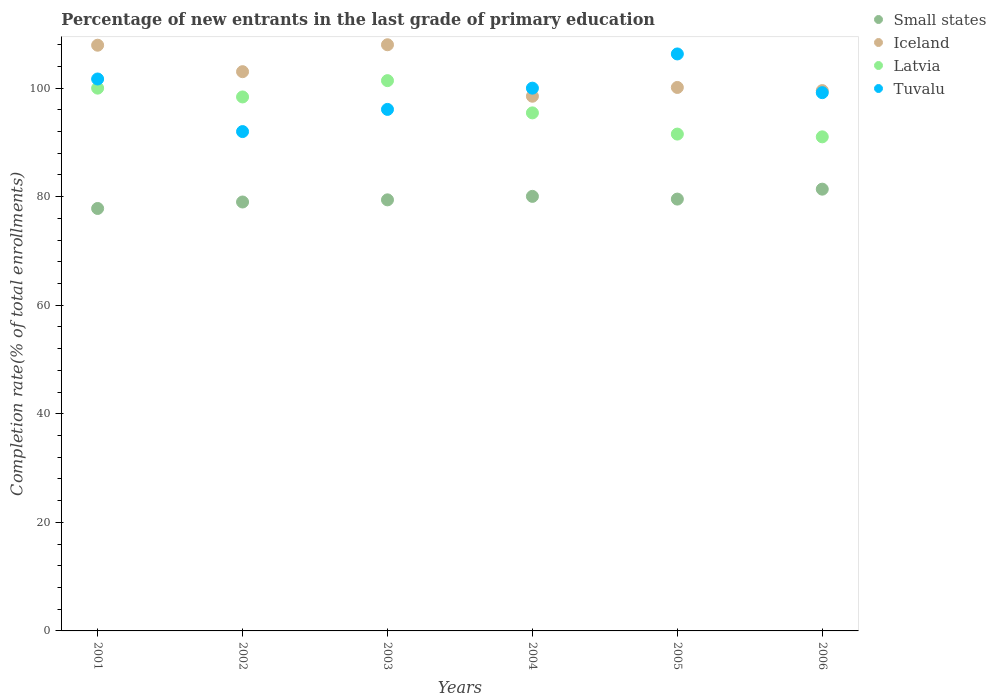How many different coloured dotlines are there?
Provide a succinct answer. 4. Is the number of dotlines equal to the number of legend labels?
Provide a succinct answer. Yes. What is the percentage of new entrants in Small states in 2002?
Ensure brevity in your answer.  79.03. Across all years, what is the maximum percentage of new entrants in Latvia?
Keep it short and to the point. 101.39. Across all years, what is the minimum percentage of new entrants in Tuvalu?
Offer a very short reply. 92. In which year was the percentage of new entrants in Iceland maximum?
Your response must be concise. 2003. In which year was the percentage of new entrants in Latvia minimum?
Provide a short and direct response. 2006. What is the total percentage of new entrants in Small states in the graph?
Offer a very short reply. 477.29. What is the difference between the percentage of new entrants in Iceland in 2001 and that in 2002?
Your response must be concise. 4.88. What is the difference between the percentage of new entrants in Small states in 2006 and the percentage of new entrants in Latvia in 2003?
Your answer should be very brief. -19.99. What is the average percentage of new entrants in Small states per year?
Offer a terse response. 79.55. In the year 2002, what is the difference between the percentage of new entrants in Tuvalu and percentage of new entrants in Latvia?
Provide a short and direct response. -6.38. In how many years, is the percentage of new entrants in Small states greater than 52 %?
Give a very brief answer. 6. What is the ratio of the percentage of new entrants in Iceland in 2003 to that in 2005?
Give a very brief answer. 1.08. Is the percentage of new entrants in Tuvalu in 2002 less than that in 2006?
Ensure brevity in your answer.  Yes. Is the difference between the percentage of new entrants in Tuvalu in 2005 and 2006 greater than the difference between the percentage of new entrants in Latvia in 2005 and 2006?
Your answer should be very brief. Yes. What is the difference between the highest and the second highest percentage of new entrants in Tuvalu?
Your answer should be compact. 4.61. What is the difference between the highest and the lowest percentage of new entrants in Small states?
Provide a succinct answer. 3.56. Is the sum of the percentage of new entrants in Tuvalu in 2003 and 2006 greater than the maximum percentage of new entrants in Latvia across all years?
Provide a short and direct response. Yes. Is it the case that in every year, the sum of the percentage of new entrants in Tuvalu and percentage of new entrants in Latvia  is greater than the percentage of new entrants in Iceland?
Provide a short and direct response. Yes. Is the percentage of new entrants in Small states strictly greater than the percentage of new entrants in Iceland over the years?
Keep it short and to the point. No. How many years are there in the graph?
Provide a succinct answer. 6. Does the graph contain any zero values?
Your answer should be very brief. No. Does the graph contain grids?
Your answer should be compact. No. Where does the legend appear in the graph?
Your answer should be very brief. Top right. How many legend labels are there?
Keep it short and to the point. 4. How are the legend labels stacked?
Offer a very short reply. Vertical. What is the title of the graph?
Provide a short and direct response. Percentage of new entrants in the last grade of primary education. What is the label or title of the Y-axis?
Offer a very short reply. Completion rate(% of total enrollments). What is the Completion rate(% of total enrollments) in Small states in 2001?
Give a very brief answer. 77.83. What is the Completion rate(% of total enrollments) of Iceland in 2001?
Make the answer very short. 107.91. What is the Completion rate(% of total enrollments) in Latvia in 2001?
Keep it short and to the point. 100. What is the Completion rate(% of total enrollments) in Tuvalu in 2001?
Give a very brief answer. 101.69. What is the Completion rate(% of total enrollments) of Small states in 2002?
Provide a short and direct response. 79.03. What is the Completion rate(% of total enrollments) of Iceland in 2002?
Offer a very short reply. 103.04. What is the Completion rate(% of total enrollments) of Latvia in 2002?
Give a very brief answer. 98.38. What is the Completion rate(% of total enrollments) of Tuvalu in 2002?
Your answer should be very brief. 92. What is the Completion rate(% of total enrollments) of Small states in 2003?
Keep it short and to the point. 79.42. What is the Completion rate(% of total enrollments) in Iceland in 2003?
Your answer should be compact. 108. What is the Completion rate(% of total enrollments) of Latvia in 2003?
Offer a very short reply. 101.39. What is the Completion rate(% of total enrollments) in Tuvalu in 2003?
Offer a terse response. 96.09. What is the Completion rate(% of total enrollments) in Small states in 2004?
Give a very brief answer. 80.06. What is the Completion rate(% of total enrollments) in Iceland in 2004?
Your answer should be very brief. 98.51. What is the Completion rate(% of total enrollments) of Latvia in 2004?
Provide a short and direct response. 95.44. What is the Completion rate(% of total enrollments) in Tuvalu in 2004?
Your answer should be compact. 100. What is the Completion rate(% of total enrollments) in Small states in 2005?
Make the answer very short. 79.56. What is the Completion rate(% of total enrollments) of Iceland in 2005?
Keep it short and to the point. 100.13. What is the Completion rate(% of total enrollments) of Latvia in 2005?
Offer a terse response. 91.54. What is the Completion rate(% of total enrollments) in Tuvalu in 2005?
Offer a very short reply. 106.3. What is the Completion rate(% of total enrollments) of Small states in 2006?
Your response must be concise. 81.39. What is the Completion rate(% of total enrollments) of Iceland in 2006?
Your answer should be compact. 99.55. What is the Completion rate(% of total enrollments) in Latvia in 2006?
Provide a succinct answer. 91.03. What is the Completion rate(% of total enrollments) in Tuvalu in 2006?
Offer a terse response. 99.17. Across all years, what is the maximum Completion rate(% of total enrollments) in Small states?
Keep it short and to the point. 81.39. Across all years, what is the maximum Completion rate(% of total enrollments) of Iceland?
Give a very brief answer. 108. Across all years, what is the maximum Completion rate(% of total enrollments) in Latvia?
Your answer should be very brief. 101.39. Across all years, what is the maximum Completion rate(% of total enrollments) in Tuvalu?
Offer a very short reply. 106.3. Across all years, what is the minimum Completion rate(% of total enrollments) in Small states?
Make the answer very short. 77.83. Across all years, what is the minimum Completion rate(% of total enrollments) in Iceland?
Your answer should be very brief. 98.51. Across all years, what is the minimum Completion rate(% of total enrollments) in Latvia?
Your answer should be very brief. 91.03. Across all years, what is the minimum Completion rate(% of total enrollments) in Tuvalu?
Your answer should be very brief. 92. What is the total Completion rate(% of total enrollments) of Small states in the graph?
Provide a succinct answer. 477.29. What is the total Completion rate(% of total enrollments) of Iceland in the graph?
Keep it short and to the point. 617.14. What is the total Completion rate(% of total enrollments) in Latvia in the graph?
Provide a short and direct response. 577.78. What is the total Completion rate(% of total enrollments) in Tuvalu in the graph?
Provide a succinct answer. 595.25. What is the difference between the Completion rate(% of total enrollments) in Small states in 2001 and that in 2002?
Give a very brief answer. -1.19. What is the difference between the Completion rate(% of total enrollments) of Iceland in 2001 and that in 2002?
Give a very brief answer. 4.88. What is the difference between the Completion rate(% of total enrollments) in Latvia in 2001 and that in 2002?
Give a very brief answer. 1.62. What is the difference between the Completion rate(% of total enrollments) in Tuvalu in 2001 and that in 2002?
Your response must be concise. 9.69. What is the difference between the Completion rate(% of total enrollments) of Small states in 2001 and that in 2003?
Your answer should be compact. -1.59. What is the difference between the Completion rate(% of total enrollments) in Iceland in 2001 and that in 2003?
Your answer should be compact. -0.08. What is the difference between the Completion rate(% of total enrollments) in Latvia in 2001 and that in 2003?
Your answer should be compact. -1.38. What is the difference between the Completion rate(% of total enrollments) of Tuvalu in 2001 and that in 2003?
Provide a short and direct response. 5.6. What is the difference between the Completion rate(% of total enrollments) of Small states in 2001 and that in 2004?
Your answer should be very brief. -2.23. What is the difference between the Completion rate(% of total enrollments) of Iceland in 2001 and that in 2004?
Provide a succinct answer. 9.4. What is the difference between the Completion rate(% of total enrollments) of Latvia in 2001 and that in 2004?
Ensure brevity in your answer.  4.56. What is the difference between the Completion rate(% of total enrollments) of Tuvalu in 2001 and that in 2004?
Make the answer very short. 1.69. What is the difference between the Completion rate(% of total enrollments) in Small states in 2001 and that in 2005?
Ensure brevity in your answer.  -1.73. What is the difference between the Completion rate(% of total enrollments) in Iceland in 2001 and that in 2005?
Offer a terse response. 7.78. What is the difference between the Completion rate(% of total enrollments) in Latvia in 2001 and that in 2005?
Your answer should be very brief. 8.47. What is the difference between the Completion rate(% of total enrollments) in Tuvalu in 2001 and that in 2005?
Offer a terse response. -4.61. What is the difference between the Completion rate(% of total enrollments) of Small states in 2001 and that in 2006?
Ensure brevity in your answer.  -3.56. What is the difference between the Completion rate(% of total enrollments) in Iceland in 2001 and that in 2006?
Your response must be concise. 8.36. What is the difference between the Completion rate(% of total enrollments) in Latvia in 2001 and that in 2006?
Provide a succinct answer. 8.97. What is the difference between the Completion rate(% of total enrollments) in Tuvalu in 2001 and that in 2006?
Your answer should be very brief. 2.52. What is the difference between the Completion rate(% of total enrollments) of Small states in 2002 and that in 2003?
Offer a terse response. -0.4. What is the difference between the Completion rate(% of total enrollments) of Iceland in 2002 and that in 2003?
Your answer should be very brief. -4.96. What is the difference between the Completion rate(% of total enrollments) in Latvia in 2002 and that in 2003?
Provide a short and direct response. -3.01. What is the difference between the Completion rate(% of total enrollments) in Tuvalu in 2002 and that in 2003?
Give a very brief answer. -4.09. What is the difference between the Completion rate(% of total enrollments) of Small states in 2002 and that in 2004?
Your answer should be very brief. -1.04. What is the difference between the Completion rate(% of total enrollments) of Iceland in 2002 and that in 2004?
Your answer should be very brief. 4.52. What is the difference between the Completion rate(% of total enrollments) in Latvia in 2002 and that in 2004?
Keep it short and to the point. 2.94. What is the difference between the Completion rate(% of total enrollments) of Small states in 2002 and that in 2005?
Offer a very short reply. -0.54. What is the difference between the Completion rate(% of total enrollments) of Iceland in 2002 and that in 2005?
Ensure brevity in your answer.  2.91. What is the difference between the Completion rate(% of total enrollments) in Latvia in 2002 and that in 2005?
Offer a very short reply. 6.84. What is the difference between the Completion rate(% of total enrollments) of Tuvalu in 2002 and that in 2005?
Keep it short and to the point. -14.3. What is the difference between the Completion rate(% of total enrollments) in Small states in 2002 and that in 2006?
Your answer should be compact. -2.37. What is the difference between the Completion rate(% of total enrollments) in Iceland in 2002 and that in 2006?
Your answer should be compact. 3.49. What is the difference between the Completion rate(% of total enrollments) of Latvia in 2002 and that in 2006?
Give a very brief answer. 7.35. What is the difference between the Completion rate(% of total enrollments) in Tuvalu in 2002 and that in 2006?
Your response must be concise. -7.17. What is the difference between the Completion rate(% of total enrollments) of Small states in 2003 and that in 2004?
Your answer should be very brief. -0.64. What is the difference between the Completion rate(% of total enrollments) in Iceland in 2003 and that in 2004?
Your response must be concise. 9.48. What is the difference between the Completion rate(% of total enrollments) of Latvia in 2003 and that in 2004?
Give a very brief answer. 5.94. What is the difference between the Completion rate(% of total enrollments) of Tuvalu in 2003 and that in 2004?
Your answer should be compact. -3.91. What is the difference between the Completion rate(% of total enrollments) of Small states in 2003 and that in 2005?
Make the answer very short. -0.14. What is the difference between the Completion rate(% of total enrollments) in Iceland in 2003 and that in 2005?
Your response must be concise. 7.86. What is the difference between the Completion rate(% of total enrollments) in Latvia in 2003 and that in 2005?
Keep it short and to the point. 9.85. What is the difference between the Completion rate(% of total enrollments) in Tuvalu in 2003 and that in 2005?
Your answer should be very brief. -10.22. What is the difference between the Completion rate(% of total enrollments) of Small states in 2003 and that in 2006?
Offer a very short reply. -1.97. What is the difference between the Completion rate(% of total enrollments) in Iceland in 2003 and that in 2006?
Give a very brief answer. 8.45. What is the difference between the Completion rate(% of total enrollments) in Latvia in 2003 and that in 2006?
Offer a terse response. 10.35. What is the difference between the Completion rate(% of total enrollments) in Tuvalu in 2003 and that in 2006?
Give a very brief answer. -3.08. What is the difference between the Completion rate(% of total enrollments) in Small states in 2004 and that in 2005?
Offer a very short reply. 0.5. What is the difference between the Completion rate(% of total enrollments) of Iceland in 2004 and that in 2005?
Your answer should be compact. -1.62. What is the difference between the Completion rate(% of total enrollments) in Latvia in 2004 and that in 2005?
Give a very brief answer. 3.91. What is the difference between the Completion rate(% of total enrollments) in Tuvalu in 2004 and that in 2005?
Offer a terse response. -6.3. What is the difference between the Completion rate(% of total enrollments) in Small states in 2004 and that in 2006?
Keep it short and to the point. -1.33. What is the difference between the Completion rate(% of total enrollments) of Iceland in 2004 and that in 2006?
Give a very brief answer. -1.04. What is the difference between the Completion rate(% of total enrollments) of Latvia in 2004 and that in 2006?
Offer a very short reply. 4.41. What is the difference between the Completion rate(% of total enrollments) of Tuvalu in 2004 and that in 2006?
Your answer should be very brief. 0.83. What is the difference between the Completion rate(% of total enrollments) of Small states in 2005 and that in 2006?
Your answer should be very brief. -1.83. What is the difference between the Completion rate(% of total enrollments) in Iceland in 2005 and that in 2006?
Provide a short and direct response. 0.58. What is the difference between the Completion rate(% of total enrollments) of Latvia in 2005 and that in 2006?
Give a very brief answer. 0.51. What is the difference between the Completion rate(% of total enrollments) of Tuvalu in 2005 and that in 2006?
Give a very brief answer. 7.13. What is the difference between the Completion rate(% of total enrollments) of Small states in 2001 and the Completion rate(% of total enrollments) of Iceland in 2002?
Provide a succinct answer. -25.2. What is the difference between the Completion rate(% of total enrollments) in Small states in 2001 and the Completion rate(% of total enrollments) in Latvia in 2002?
Make the answer very short. -20.55. What is the difference between the Completion rate(% of total enrollments) of Small states in 2001 and the Completion rate(% of total enrollments) of Tuvalu in 2002?
Offer a very short reply. -14.17. What is the difference between the Completion rate(% of total enrollments) of Iceland in 2001 and the Completion rate(% of total enrollments) of Latvia in 2002?
Provide a succinct answer. 9.53. What is the difference between the Completion rate(% of total enrollments) of Iceland in 2001 and the Completion rate(% of total enrollments) of Tuvalu in 2002?
Your answer should be compact. 15.91. What is the difference between the Completion rate(% of total enrollments) of Latvia in 2001 and the Completion rate(% of total enrollments) of Tuvalu in 2002?
Provide a succinct answer. 8. What is the difference between the Completion rate(% of total enrollments) of Small states in 2001 and the Completion rate(% of total enrollments) of Iceland in 2003?
Offer a very short reply. -30.16. What is the difference between the Completion rate(% of total enrollments) in Small states in 2001 and the Completion rate(% of total enrollments) in Latvia in 2003?
Your response must be concise. -23.55. What is the difference between the Completion rate(% of total enrollments) of Small states in 2001 and the Completion rate(% of total enrollments) of Tuvalu in 2003?
Make the answer very short. -18.25. What is the difference between the Completion rate(% of total enrollments) of Iceland in 2001 and the Completion rate(% of total enrollments) of Latvia in 2003?
Offer a very short reply. 6.53. What is the difference between the Completion rate(% of total enrollments) in Iceland in 2001 and the Completion rate(% of total enrollments) in Tuvalu in 2003?
Make the answer very short. 11.83. What is the difference between the Completion rate(% of total enrollments) of Latvia in 2001 and the Completion rate(% of total enrollments) of Tuvalu in 2003?
Offer a terse response. 3.92. What is the difference between the Completion rate(% of total enrollments) of Small states in 2001 and the Completion rate(% of total enrollments) of Iceland in 2004?
Provide a short and direct response. -20.68. What is the difference between the Completion rate(% of total enrollments) in Small states in 2001 and the Completion rate(% of total enrollments) in Latvia in 2004?
Provide a succinct answer. -17.61. What is the difference between the Completion rate(% of total enrollments) of Small states in 2001 and the Completion rate(% of total enrollments) of Tuvalu in 2004?
Your answer should be very brief. -22.17. What is the difference between the Completion rate(% of total enrollments) of Iceland in 2001 and the Completion rate(% of total enrollments) of Latvia in 2004?
Offer a very short reply. 12.47. What is the difference between the Completion rate(% of total enrollments) of Iceland in 2001 and the Completion rate(% of total enrollments) of Tuvalu in 2004?
Offer a terse response. 7.91. What is the difference between the Completion rate(% of total enrollments) in Latvia in 2001 and the Completion rate(% of total enrollments) in Tuvalu in 2004?
Your answer should be very brief. 0. What is the difference between the Completion rate(% of total enrollments) in Small states in 2001 and the Completion rate(% of total enrollments) in Iceland in 2005?
Your response must be concise. -22.3. What is the difference between the Completion rate(% of total enrollments) in Small states in 2001 and the Completion rate(% of total enrollments) in Latvia in 2005?
Keep it short and to the point. -13.7. What is the difference between the Completion rate(% of total enrollments) of Small states in 2001 and the Completion rate(% of total enrollments) of Tuvalu in 2005?
Give a very brief answer. -28.47. What is the difference between the Completion rate(% of total enrollments) of Iceland in 2001 and the Completion rate(% of total enrollments) of Latvia in 2005?
Offer a terse response. 16.37. What is the difference between the Completion rate(% of total enrollments) in Iceland in 2001 and the Completion rate(% of total enrollments) in Tuvalu in 2005?
Offer a terse response. 1.61. What is the difference between the Completion rate(% of total enrollments) of Latvia in 2001 and the Completion rate(% of total enrollments) of Tuvalu in 2005?
Ensure brevity in your answer.  -6.3. What is the difference between the Completion rate(% of total enrollments) of Small states in 2001 and the Completion rate(% of total enrollments) of Iceland in 2006?
Make the answer very short. -21.72. What is the difference between the Completion rate(% of total enrollments) of Small states in 2001 and the Completion rate(% of total enrollments) of Latvia in 2006?
Your answer should be very brief. -13.2. What is the difference between the Completion rate(% of total enrollments) in Small states in 2001 and the Completion rate(% of total enrollments) in Tuvalu in 2006?
Give a very brief answer. -21.34. What is the difference between the Completion rate(% of total enrollments) in Iceland in 2001 and the Completion rate(% of total enrollments) in Latvia in 2006?
Make the answer very short. 16.88. What is the difference between the Completion rate(% of total enrollments) in Iceland in 2001 and the Completion rate(% of total enrollments) in Tuvalu in 2006?
Keep it short and to the point. 8.74. What is the difference between the Completion rate(% of total enrollments) of Latvia in 2001 and the Completion rate(% of total enrollments) of Tuvalu in 2006?
Make the answer very short. 0.83. What is the difference between the Completion rate(% of total enrollments) in Small states in 2002 and the Completion rate(% of total enrollments) in Iceland in 2003?
Your answer should be very brief. -28.97. What is the difference between the Completion rate(% of total enrollments) of Small states in 2002 and the Completion rate(% of total enrollments) of Latvia in 2003?
Provide a succinct answer. -22.36. What is the difference between the Completion rate(% of total enrollments) of Small states in 2002 and the Completion rate(% of total enrollments) of Tuvalu in 2003?
Offer a very short reply. -17.06. What is the difference between the Completion rate(% of total enrollments) of Iceland in 2002 and the Completion rate(% of total enrollments) of Latvia in 2003?
Your answer should be compact. 1.65. What is the difference between the Completion rate(% of total enrollments) of Iceland in 2002 and the Completion rate(% of total enrollments) of Tuvalu in 2003?
Provide a short and direct response. 6.95. What is the difference between the Completion rate(% of total enrollments) in Latvia in 2002 and the Completion rate(% of total enrollments) in Tuvalu in 2003?
Ensure brevity in your answer.  2.29. What is the difference between the Completion rate(% of total enrollments) of Small states in 2002 and the Completion rate(% of total enrollments) of Iceland in 2004?
Ensure brevity in your answer.  -19.49. What is the difference between the Completion rate(% of total enrollments) of Small states in 2002 and the Completion rate(% of total enrollments) of Latvia in 2004?
Give a very brief answer. -16.42. What is the difference between the Completion rate(% of total enrollments) in Small states in 2002 and the Completion rate(% of total enrollments) in Tuvalu in 2004?
Your answer should be compact. -20.97. What is the difference between the Completion rate(% of total enrollments) in Iceland in 2002 and the Completion rate(% of total enrollments) in Latvia in 2004?
Offer a terse response. 7.59. What is the difference between the Completion rate(% of total enrollments) of Iceland in 2002 and the Completion rate(% of total enrollments) of Tuvalu in 2004?
Offer a very short reply. 3.04. What is the difference between the Completion rate(% of total enrollments) of Latvia in 2002 and the Completion rate(% of total enrollments) of Tuvalu in 2004?
Your answer should be compact. -1.62. What is the difference between the Completion rate(% of total enrollments) in Small states in 2002 and the Completion rate(% of total enrollments) in Iceland in 2005?
Your answer should be compact. -21.11. What is the difference between the Completion rate(% of total enrollments) of Small states in 2002 and the Completion rate(% of total enrollments) of Latvia in 2005?
Provide a short and direct response. -12.51. What is the difference between the Completion rate(% of total enrollments) in Small states in 2002 and the Completion rate(% of total enrollments) in Tuvalu in 2005?
Make the answer very short. -27.28. What is the difference between the Completion rate(% of total enrollments) of Iceland in 2002 and the Completion rate(% of total enrollments) of Latvia in 2005?
Your response must be concise. 11.5. What is the difference between the Completion rate(% of total enrollments) in Iceland in 2002 and the Completion rate(% of total enrollments) in Tuvalu in 2005?
Provide a short and direct response. -3.27. What is the difference between the Completion rate(% of total enrollments) in Latvia in 2002 and the Completion rate(% of total enrollments) in Tuvalu in 2005?
Your answer should be very brief. -7.92. What is the difference between the Completion rate(% of total enrollments) of Small states in 2002 and the Completion rate(% of total enrollments) of Iceland in 2006?
Provide a succinct answer. -20.52. What is the difference between the Completion rate(% of total enrollments) of Small states in 2002 and the Completion rate(% of total enrollments) of Latvia in 2006?
Offer a very short reply. -12.01. What is the difference between the Completion rate(% of total enrollments) of Small states in 2002 and the Completion rate(% of total enrollments) of Tuvalu in 2006?
Give a very brief answer. -20.14. What is the difference between the Completion rate(% of total enrollments) of Iceland in 2002 and the Completion rate(% of total enrollments) of Latvia in 2006?
Provide a short and direct response. 12.01. What is the difference between the Completion rate(% of total enrollments) in Iceland in 2002 and the Completion rate(% of total enrollments) in Tuvalu in 2006?
Provide a succinct answer. 3.87. What is the difference between the Completion rate(% of total enrollments) in Latvia in 2002 and the Completion rate(% of total enrollments) in Tuvalu in 2006?
Give a very brief answer. -0.79. What is the difference between the Completion rate(% of total enrollments) of Small states in 2003 and the Completion rate(% of total enrollments) of Iceland in 2004?
Offer a very short reply. -19.09. What is the difference between the Completion rate(% of total enrollments) in Small states in 2003 and the Completion rate(% of total enrollments) in Latvia in 2004?
Your answer should be compact. -16.02. What is the difference between the Completion rate(% of total enrollments) of Small states in 2003 and the Completion rate(% of total enrollments) of Tuvalu in 2004?
Your answer should be very brief. -20.58. What is the difference between the Completion rate(% of total enrollments) in Iceland in 2003 and the Completion rate(% of total enrollments) in Latvia in 2004?
Provide a short and direct response. 12.55. What is the difference between the Completion rate(% of total enrollments) in Iceland in 2003 and the Completion rate(% of total enrollments) in Tuvalu in 2004?
Make the answer very short. 8. What is the difference between the Completion rate(% of total enrollments) of Latvia in 2003 and the Completion rate(% of total enrollments) of Tuvalu in 2004?
Provide a succinct answer. 1.39. What is the difference between the Completion rate(% of total enrollments) of Small states in 2003 and the Completion rate(% of total enrollments) of Iceland in 2005?
Provide a succinct answer. -20.71. What is the difference between the Completion rate(% of total enrollments) in Small states in 2003 and the Completion rate(% of total enrollments) in Latvia in 2005?
Ensure brevity in your answer.  -12.12. What is the difference between the Completion rate(% of total enrollments) in Small states in 2003 and the Completion rate(% of total enrollments) in Tuvalu in 2005?
Provide a short and direct response. -26.88. What is the difference between the Completion rate(% of total enrollments) in Iceland in 2003 and the Completion rate(% of total enrollments) in Latvia in 2005?
Your response must be concise. 16.46. What is the difference between the Completion rate(% of total enrollments) of Iceland in 2003 and the Completion rate(% of total enrollments) of Tuvalu in 2005?
Your answer should be compact. 1.69. What is the difference between the Completion rate(% of total enrollments) in Latvia in 2003 and the Completion rate(% of total enrollments) in Tuvalu in 2005?
Ensure brevity in your answer.  -4.92. What is the difference between the Completion rate(% of total enrollments) in Small states in 2003 and the Completion rate(% of total enrollments) in Iceland in 2006?
Provide a succinct answer. -20.13. What is the difference between the Completion rate(% of total enrollments) in Small states in 2003 and the Completion rate(% of total enrollments) in Latvia in 2006?
Your response must be concise. -11.61. What is the difference between the Completion rate(% of total enrollments) of Small states in 2003 and the Completion rate(% of total enrollments) of Tuvalu in 2006?
Keep it short and to the point. -19.75. What is the difference between the Completion rate(% of total enrollments) of Iceland in 2003 and the Completion rate(% of total enrollments) of Latvia in 2006?
Provide a succinct answer. 16.96. What is the difference between the Completion rate(% of total enrollments) of Iceland in 2003 and the Completion rate(% of total enrollments) of Tuvalu in 2006?
Your response must be concise. 8.83. What is the difference between the Completion rate(% of total enrollments) in Latvia in 2003 and the Completion rate(% of total enrollments) in Tuvalu in 2006?
Your answer should be compact. 2.22. What is the difference between the Completion rate(% of total enrollments) in Small states in 2004 and the Completion rate(% of total enrollments) in Iceland in 2005?
Your answer should be very brief. -20.07. What is the difference between the Completion rate(% of total enrollments) in Small states in 2004 and the Completion rate(% of total enrollments) in Latvia in 2005?
Your answer should be very brief. -11.48. What is the difference between the Completion rate(% of total enrollments) of Small states in 2004 and the Completion rate(% of total enrollments) of Tuvalu in 2005?
Provide a short and direct response. -26.24. What is the difference between the Completion rate(% of total enrollments) in Iceland in 2004 and the Completion rate(% of total enrollments) in Latvia in 2005?
Ensure brevity in your answer.  6.97. What is the difference between the Completion rate(% of total enrollments) in Iceland in 2004 and the Completion rate(% of total enrollments) in Tuvalu in 2005?
Provide a succinct answer. -7.79. What is the difference between the Completion rate(% of total enrollments) of Latvia in 2004 and the Completion rate(% of total enrollments) of Tuvalu in 2005?
Offer a very short reply. -10.86. What is the difference between the Completion rate(% of total enrollments) of Small states in 2004 and the Completion rate(% of total enrollments) of Iceland in 2006?
Your answer should be compact. -19.49. What is the difference between the Completion rate(% of total enrollments) in Small states in 2004 and the Completion rate(% of total enrollments) in Latvia in 2006?
Ensure brevity in your answer.  -10.97. What is the difference between the Completion rate(% of total enrollments) in Small states in 2004 and the Completion rate(% of total enrollments) in Tuvalu in 2006?
Your response must be concise. -19.11. What is the difference between the Completion rate(% of total enrollments) in Iceland in 2004 and the Completion rate(% of total enrollments) in Latvia in 2006?
Offer a terse response. 7.48. What is the difference between the Completion rate(% of total enrollments) in Iceland in 2004 and the Completion rate(% of total enrollments) in Tuvalu in 2006?
Give a very brief answer. -0.66. What is the difference between the Completion rate(% of total enrollments) in Latvia in 2004 and the Completion rate(% of total enrollments) in Tuvalu in 2006?
Keep it short and to the point. -3.73. What is the difference between the Completion rate(% of total enrollments) of Small states in 2005 and the Completion rate(% of total enrollments) of Iceland in 2006?
Provide a short and direct response. -19.99. What is the difference between the Completion rate(% of total enrollments) of Small states in 2005 and the Completion rate(% of total enrollments) of Latvia in 2006?
Make the answer very short. -11.47. What is the difference between the Completion rate(% of total enrollments) in Small states in 2005 and the Completion rate(% of total enrollments) in Tuvalu in 2006?
Offer a terse response. -19.61. What is the difference between the Completion rate(% of total enrollments) in Iceland in 2005 and the Completion rate(% of total enrollments) in Latvia in 2006?
Keep it short and to the point. 9.1. What is the difference between the Completion rate(% of total enrollments) of Iceland in 2005 and the Completion rate(% of total enrollments) of Tuvalu in 2006?
Keep it short and to the point. 0.96. What is the difference between the Completion rate(% of total enrollments) of Latvia in 2005 and the Completion rate(% of total enrollments) of Tuvalu in 2006?
Your response must be concise. -7.63. What is the average Completion rate(% of total enrollments) of Small states per year?
Your response must be concise. 79.55. What is the average Completion rate(% of total enrollments) in Iceland per year?
Offer a very short reply. 102.86. What is the average Completion rate(% of total enrollments) of Latvia per year?
Make the answer very short. 96.3. What is the average Completion rate(% of total enrollments) of Tuvalu per year?
Provide a succinct answer. 99.21. In the year 2001, what is the difference between the Completion rate(% of total enrollments) of Small states and Completion rate(% of total enrollments) of Iceland?
Give a very brief answer. -30.08. In the year 2001, what is the difference between the Completion rate(% of total enrollments) of Small states and Completion rate(% of total enrollments) of Latvia?
Your response must be concise. -22.17. In the year 2001, what is the difference between the Completion rate(% of total enrollments) of Small states and Completion rate(% of total enrollments) of Tuvalu?
Ensure brevity in your answer.  -23.85. In the year 2001, what is the difference between the Completion rate(% of total enrollments) of Iceland and Completion rate(% of total enrollments) of Latvia?
Ensure brevity in your answer.  7.91. In the year 2001, what is the difference between the Completion rate(% of total enrollments) in Iceland and Completion rate(% of total enrollments) in Tuvalu?
Your response must be concise. 6.22. In the year 2001, what is the difference between the Completion rate(% of total enrollments) of Latvia and Completion rate(% of total enrollments) of Tuvalu?
Your response must be concise. -1.68. In the year 2002, what is the difference between the Completion rate(% of total enrollments) in Small states and Completion rate(% of total enrollments) in Iceland?
Your response must be concise. -24.01. In the year 2002, what is the difference between the Completion rate(% of total enrollments) of Small states and Completion rate(% of total enrollments) of Latvia?
Your response must be concise. -19.35. In the year 2002, what is the difference between the Completion rate(% of total enrollments) in Small states and Completion rate(% of total enrollments) in Tuvalu?
Your answer should be compact. -12.97. In the year 2002, what is the difference between the Completion rate(% of total enrollments) in Iceland and Completion rate(% of total enrollments) in Latvia?
Make the answer very short. 4.66. In the year 2002, what is the difference between the Completion rate(% of total enrollments) of Iceland and Completion rate(% of total enrollments) of Tuvalu?
Ensure brevity in your answer.  11.04. In the year 2002, what is the difference between the Completion rate(% of total enrollments) of Latvia and Completion rate(% of total enrollments) of Tuvalu?
Make the answer very short. 6.38. In the year 2003, what is the difference between the Completion rate(% of total enrollments) of Small states and Completion rate(% of total enrollments) of Iceland?
Provide a succinct answer. -28.57. In the year 2003, what is the difference between the Completion rate(% of total enrollments) of Small states and Completion rate(% of total enrollments) of Latvia?
Your answer should be compact. -21.96. In the year 2003, what is the difference between the Completion rate(% of total enrollments) of Small states and Completion rate(% of total enrollments) of Tuvalu?
Your response must be concise. -16.67. In the year 2003, what is the difference between the Completion rate(% of total enrollments) of Iceland and Completion rate(% of total enrollments) of Latvia?
Provide a succinct answer. 6.61. In the year 2003, what is the difference between the Completion rate(% of total enrollments) of Iceland and Completion rate(% of total enrollments) of Tuvalu?
Make the answer very short. 11.91. In the year 2003, what is the difference between the Completion rate(% of total enrollments) of Latvia and Completion rate(% of total enrollments) of Tuvalu?
Offer a very short reply. 5.3. In the year 2004, what is the difference between the Completion rate(% of total enrollments) of Small states and Completion rate(% of total enrollments) of Iceland?
Your answer should be compact. -18.45. In the year 2004, what is the difference between the Completion rate(% of total enrollments) in Small states and Completion rate(% of total enrollments) in Latvia?
Provide a succinct answer. -15.38. In the year 2004, what is the difference between the Completion rate(% of total enrollments) of Small states and Completion rate(% of total enrollments) of Tuvalu?
Your response must be concise. -19.94. In the year 2004, what is the difference between the Completion rate(% of total enrollments) of Iceland and Completion rate(% of total enrollments) of Latvia?
Offer a terse response. 3.07. In the year 2004, what is the difference between the Completion rate(% of total enrollments) in Iceland and Completion rate(% of total enrollments) in Tuvalu?
Your answer should be compact. -1.49. In the year 2004, what is the difference between the Completion rate(% of total enrollments) in Latvia and Completion rate(% of total enrollments) in Tuvalu?
Provide a succinct answer. -4.56. In the year 2005, what is the difference between the Completion rate(% of total enrollments) of Small states and Completion rate(% of total enrollments) of Iceland?
Make the answer very short. -20.57. In the year 2005, what is the difference between the Completion rate(% of total enrollments) in Small states and Completion rate(% of total enrollments) in Latvia?
Give a very brief answer. -11.98. In the year 2005, what is the difference between the Completion rate(% of total enrollments) of Small states and Completion rate(% of total enrollments) of Tuvalu?
Offer a very short reply. -26.74. In the year 2005, what is the difference between the Completion rate(% of total enrollments) of Iceland and Completion rate(% of total enrollments) of Latvia?
Ensure brevity in your answer.  8.59. In the year 2005, what is the difference between the Completion rate(% of total enrollments) in Iceland and Completion rate(% of total enrollments) in Tuvalu?
Offer a terse response. -6.17. In the year 2005, what is the difference between the Completion rate(% of total enrollments) in Latvia and Completion rate(% of total enrollments) in Tuvalu?
Your answer should be compact. -14.76. In the year 2006, what is the difference between the Completion rate(% of total enrollments) of Small states and Completion rate(% of total enrollments) of Iceland?
Give a very brief answer. -18.16. In the year 2006, what is the difference between the Completion rate(% of total enrollments) in Small states and Completion rate(% of total enrollments) in Latvia?
Your answer should be very brief. -9.64. In the year 2006, what is the difference between the Completion rate(% of total enrollments) in Small states and Completion rate(% of total enrollments) in Tuvalu?
Make the answer very short. -17.78. In the year 2006, what is the difference between the Completion rate(% of total enrollments) of Iceland and Completion rate(% of total enrollments) of Latvia?
Your response must be concise. 8.52. In the year 2006, what is the difference between the Completion rate(% of total enrollments) in Iceland and Completion rate(% of total enrollments) in Tuvalu?
Give a very brief answer. 0.38. In the year 2006, what is the difference between the Completion rate(% of total enrollments) in Latvia and Completion rate(% of total enrollments) in Tuvalu?
Make the answer very short. -8.14. What is the ratio of the Completion rate(% of total enrollments) of Small states in 2001 to that in 2002?
Offer a terse response. 0.98. What is the ratio of the Completion rate(% of total enrollments) in Iceland in 2001 to that in 2002?
Provide a short and direct response. 1.05. What is the ratio of the Completion rate(% of total enrollments) of Latvia in 2001 to that in 2002?
Your answer should be very brief. 1.02. What is the ratio of the Completion rate(% of total enrollments) of Tuvalu in 2001 to that in 2002?
Offer a very short reply. 1.11. What is the ratio of the Completion rate(% of total enrollments) in Iceland in 2001 to that in 2003?
Keep it short and to the point. 1. What is the ratio of the Completion rate(% of total enrollments) of Latvia in 2001 to that in 2003?
Your answer should be compact. 0.99. What is the ratio of the Completion rate(% of total enrollments) in Tuvalu in 2001 to that in 2003?
Provide a succinct answer. 1.06. What is the ratio of the Completion rate(% of total enrollments) in Small states in 2001 to that in 2004?
Give a very brief answer. 0.97. What is the ratio of the Completion rate(% of total enrollments) in Iceland in 2001 to that in 2004?
Keep it short and to the point. 1.1. What is the ratio of the Completion rate(% of total enrollments) of Latvia in 2001 to that in 2004?
Provide a short and direct response. 1.05. What is the ratio of the Completion rate(% of total enrollments) in Tuvalu in 2001 to that in 2004?
Offer a very short reply. 1.02. What is the ratio of the Completion rate(% of total enrollments) of Small states in 2001 to that in 2005?
Your answer should be compact. 0.98. What is the ratio of the Completion rate(% of total enrollments) in Iceland in 2001 to that in 2005?
Provide a short and direct response. 1.08. What is the ratio of the Completion rate(% of total enrollments) in Latvia in 2001 to that in 2005?
Your answer should be very brief. 1.09. What is the ratio of the Completion rate(% of total enrollments) of Tuvalu in 2001 to that in 2005?
Your answer should be compact. 0.96. What is the ratio of the Completion rate(% of total enrollments) of Small states in 2001 to that in 2006?
Your answer should be compact. 0.96. What is the ratio of the Completion rate(% of total enrollments) in Iceland in 2001 to that in 2006?
Your answer should be very brief. 1.08. What is the ratio of the Completion rate(% of total enrollments) of Latvia in 2001 to that in 2006?
Offer a terse response. 1.1. What is the ratio of the Completion rate(% of total enrollments) of Tuvalu in 2001 to that in 2006?
Make the answer very short. 1.03. What is the ratio of the Completion rate(% of total enrollments) of Small states in 2002 to that in 2003?
Your answer should be very brief. 0.99. What is the ratio of the Completion rate(% of total enrollments) of Iceland in 2002 to that in 2003?
Your response must be concise. 0.95. What is the ratio of the Completion rate(% of total enrollments) of Latvia in 2002 to that in 2003?
Offer a terse response. 0.97. What is the ratio of the Completion rate(% of total enrollments) of Tuvalu in 2002 to that in 2003?
Give a very brief answer. 0.96. What is the ratio of the Completion rate(% of total enrollments) in Small states in 2002 to that in 2004?
Provide a succinct answer. 0.99. What is the ratio of the Completion rate(% of total enrollments) in Iceland in 2002 to that in 2004?
Your response must be concise. 1.05. What is the ratio of the Completion rate(% of total enrollments) in Latvia in 2002 to that in 2004?
Offer a terse response. 1.03. What is the ratio of the Completion rate(% of total enrollments) of Iceland in 2002 to that in 2005?
Keep it short and to the point. 1.03. What is the ratio of the Completion rate(% of total enrollments) in Latvia in 2002 to that in 2005?
Offer a terse response. 1.07. What is the ratio of the Completion rate(% of total enrollments) in Tuvalu in 2002 to that in 2005?
Your response must be concise. 0.87. What is the ratio of the Completion rate(% of total enrollments) of Small states in 2002 to that in 2006?
Make the answer very short. 0.97. What is the ratio of the Completion rate(% of total enrollments) in Iceland in 2002 to that in 2006?
Your answer should be compact. 1.03. What is the ratio of the Completion rate(% of total enrollments) in Latvia in 2002 to that in 2006?
Offer a very short reply. 1.08. What is the ratio of the Completion rate(% of total enrollments) in Tuvalu in 2002 to that in 2006?
Give a very brief answer. 0.93. What is the ratio of the Completion rate(% of total enrollments) in Iceland in 2003 to that in 2004?
Your answer should be compact. 1.1. What is the ratio of the Completion rate(% of total enrollments) in Latvia in 2003 to that in 2004?
Offer a terse response. 1.06. What is the ratio of the Completion rate(% of total enrollments) of Tuvalu in 2003 to that in 2004?
Your answer should be compact. 0.96. What is the ratio of the Completion rate(% of total enrollments) in Small states in 2003 to that in 2005?
Offer a very short reply. 1. What is the ratio of the Completion rate(% of total enrollments) of Iceland in 2003 to that in 2005?
Make the answer very short. 1.08. What is the ratio of the Completion rate(% of total enrollments) in Latvia in 2003 to that in 2005?
Give a very brief answer. 1.11. What is the ratio of the Completion rate(% of total enrollments) in Tuvalu in 2003 to that in 2005?
Offer a terse response. 0.9. What is the ratio of the Completion rate(% of total enrollments) in Small states in 2003 to that in 2006?
Offer a terse response. 0.98. What is the ratio of the Completion rate(% of total enrollments) of Iceland in 2003 to that in 2006?
Offer a terse response. 1.08. What is the ratio of the Completion rate(% of total enrollments) in Latvia in 2003 to that in 2006?
Your response must be concise. 1.11. What is the ratio of the Completion rate(% of total enrollments) of Tuvalu in 2003 to that in 2006?
Provide a short and direct response. 0.97. What is the ratio of the Completion rate(% of total enrollments) in Small states in 2004 to that in 2005?
Provide a short and direct response. 1.01. What is the ratio of the Completion rate(% of total enrollments) of Iceland in 2004 to that in 2005?
Your response must be concise. 0.98. What is the ratio of the Completion rate(% of total enrollments) in Latvia in 2004 to that in 2005?
Your answer should be very brief. 1.04. What is the ratio of the Completion rate(% of total enrollments) of Tuvalu in 2004 to that in 2005?
Make the answer very short. 0.94. What is the ratio of the Completion rate(% of total enrollments) of Small states in 2004 to that in 2006?
Ensure brevity in your answer.  0.98. What is the ratio of the Completion rate(% of total enrollments) in Iceland in 2004 to that in 2006?
Your answer should be compact. 0.99. What is the ratio of the Completion rate(% of total enrollments) in Latvia in 2004 to that in 2006?
Your answer should be compact. 1.05. What is the ratio of the Completion rate(% of total enrollments) in Tuvalu in 2004 to that in 2006?
Your answer should be very brief. 1.01. What is the ratio of the Completion rate(% of total enrollments) in Small states in 2005 to that in 2006?
Your answer should be very brief. 0.98. What is the ratio of the Completion rate(% of total enrollments) in Latvia in 2005 to that in 2006?
Your answer should be compact. 1.01. What is the ratio of the Completion rate(% of total enrollments) of Tuvalu in 2005 to that in 2006?
Your answer should be very brief. 1.07. What is the difference between the highest and the second highest Completion rate(% of total enrollments) in Small states?
Provide a succinct answer. 1.33. What is the difference between the highest and the second highest Completion rate(% of total enrollments) of Iceland?
Your response must be concise. 0.08. What is the difference between the highest and the second highest Completion rate(% of total enrollments) of Latvia?
Your answer should be compact. 1.38. What is the difference between the highest and the second highest Completion rate(% of total enrollments) in Tuvalu?
Give a very brief answer. 4.61. What is the difference between the highest and the lowest Completion rate(% of total enrollments) of Small states?
Your answer should be compact. 3.56. What is the difference between the highest and the lowest Completion rate(% of total enrollments) of Iceland?
Offer a very short reply. 9.48. What is the difference between the highest and the lowest Completion rate(% of total enrollments) of Latvia?
Keep it short and to the point. 10.35. What is the difference between the highest and the lowest Completion rate(% of total enrollments) in Tuvalu?
Offer a very short reply. 14.3. 